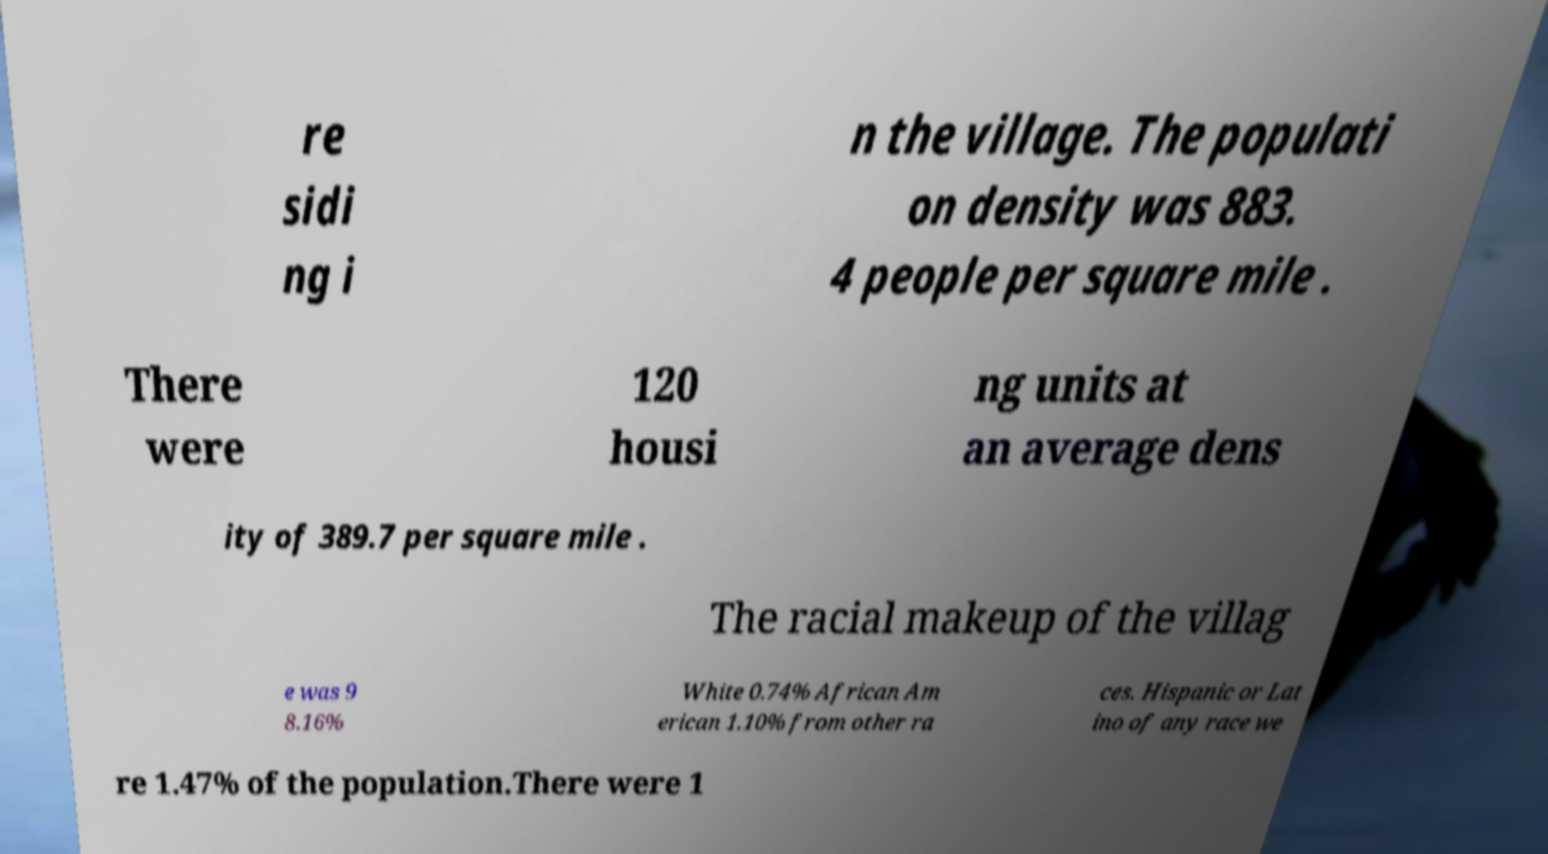Could you assist in decoding the text presented in this image and type it out clearly? re sidi ng i n the village. The populati on density was 883. 4 people per square mile . There were 120 housi ng units at an average dens ity of 389.7 per square mile . The racial makeup of the villag e was 9 8.16% White 0.74% African Am erican 1.10% from other ra ces. Hispanic or Lat ino of any race we re 1.47% of the population.There were 1 